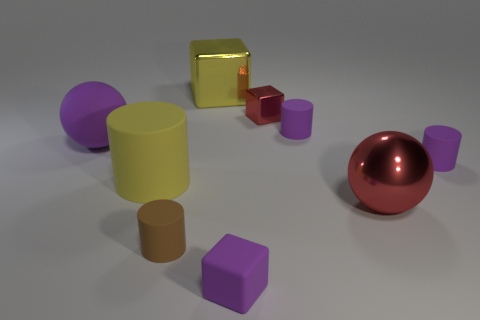Subtract all red balls. How many purple cylinders are left? 2 Subtract all shiny cubes. How many cubes are left? 1 Subtract all yellow cylinders. How many cylinders are left? 3 Subtract 1 cylinders. How many cylinders are left? 3 Add 1 red metal objects. How many objects exist? 10 Subtract all blue cylinders. Subtract all brown balls. How many cylinders are left? 4 Subtract all spheres. How many objects are left? 7 Add 2 big yellow rubber cylinders. How many big yellow rubber cylinders exist? 3 Subtract 1 purple cylinders. How many objects are left? 8 Subtract all yellow rubber objects. Subtract all brown matte things. How many objects are left? 7 